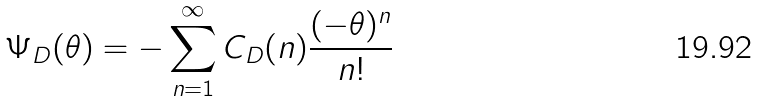Convert formula to latex. <formula><loc_0><loc_0><loc_500><loc_500>\Psi _ { D } ( \theta ) = - \sum _ { n = 1 } ^ { \infty } C _ { D } ( n ) \frac { ( - \theta ) ^ { n } } { n ! }</formula> 